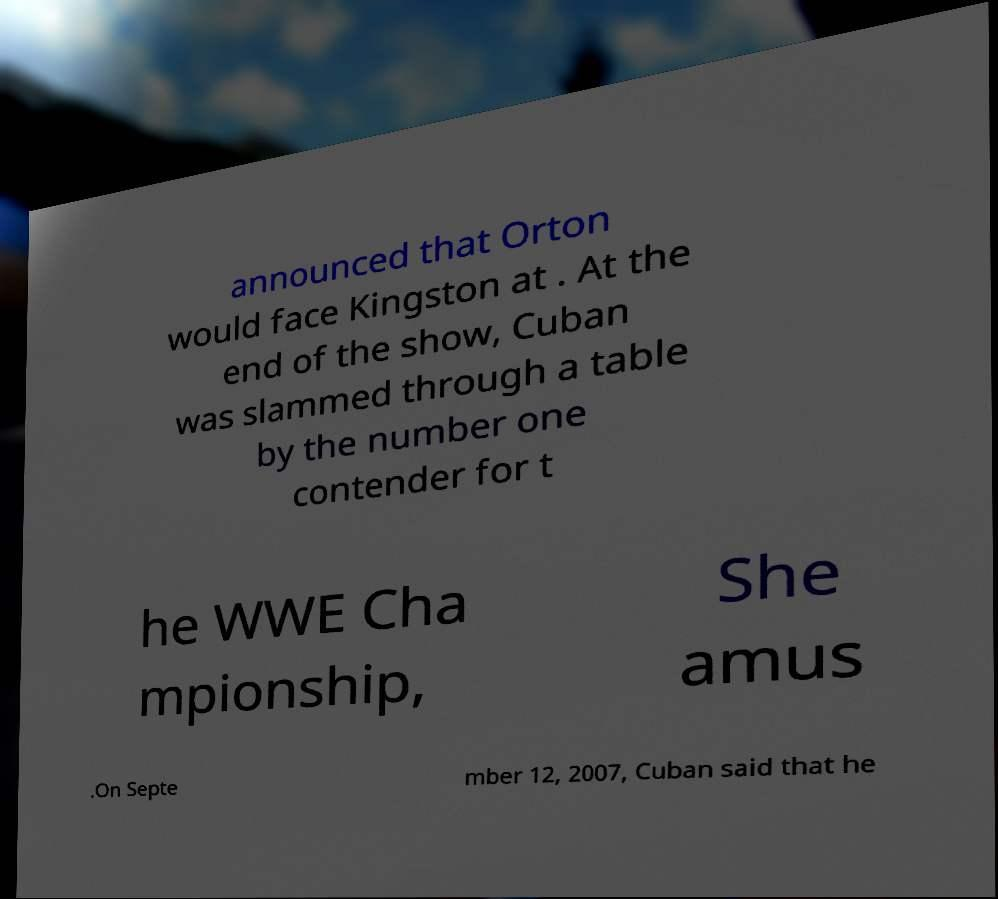Please identify and transcribe the text found in this image. announced that Orton would face Kingston at . At the end of the show, Cuban was slammed through a table by the number one contender for t he WWE Cha mpionship, She amus .On Septe mber 12, 2007, Cuban said that he 